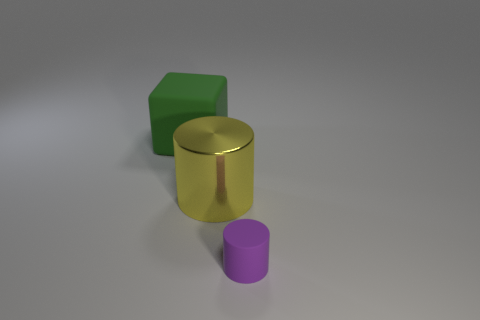Add 2 small green rubber balls. How many objects exist? 5 Subtract all cubes. How many objects are left? 2 Add 2 tiny rubber things. How many tiny rubber things exist? 3 Subtract 0 green cylinders. How many objects are left? 3 Subtract all rubber blocks. Subtract all purple matte cylinders. How many objects are left? 1 Add 3 green cubes. How many green cubes are left? 4 